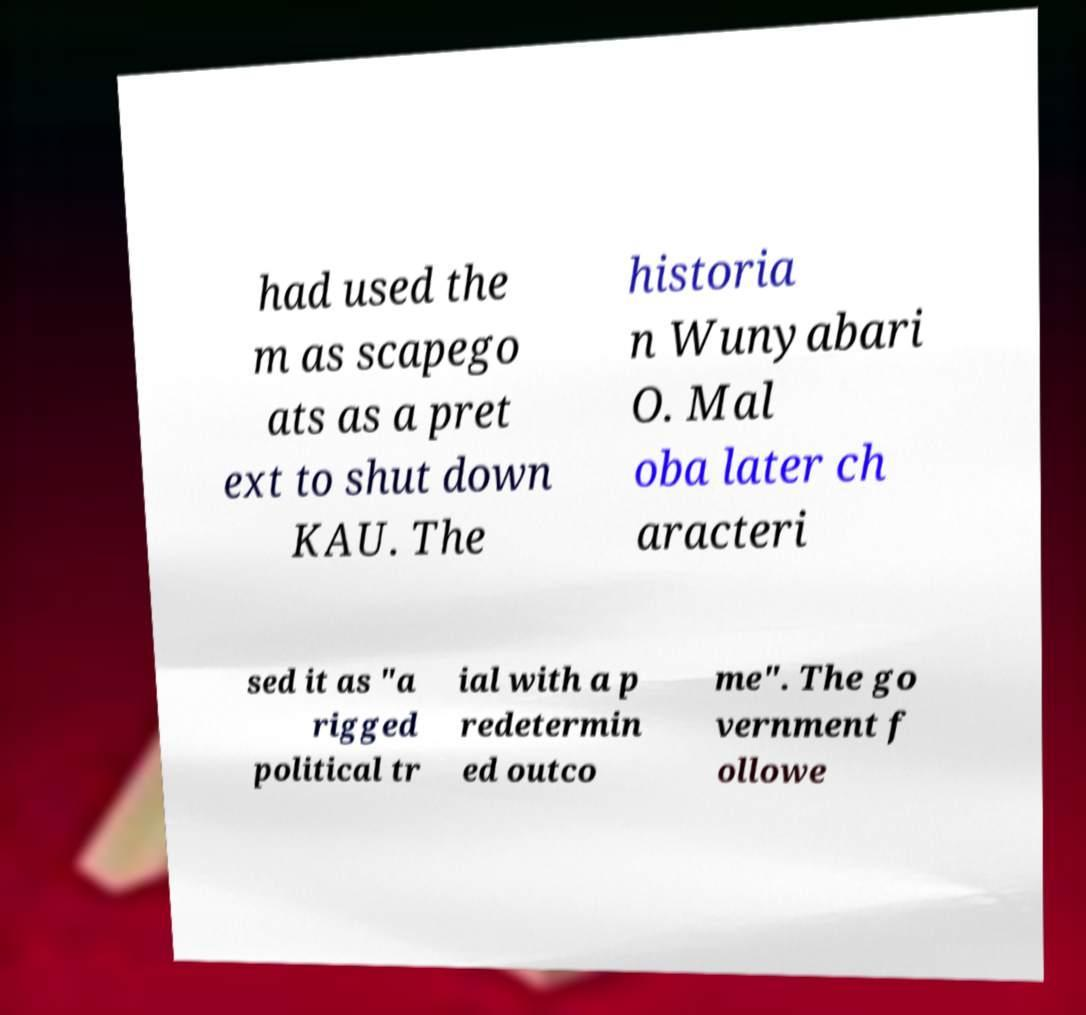Could you extract and type out the text from this image? had used the m as scapego ats as a pret ext to shut down KAU. The historia n Wunyabari O. Mal oba later ch aracteri sed it as "a rigged political tr ial with a p redetermin ed outco me". The go vernment f ollowe 